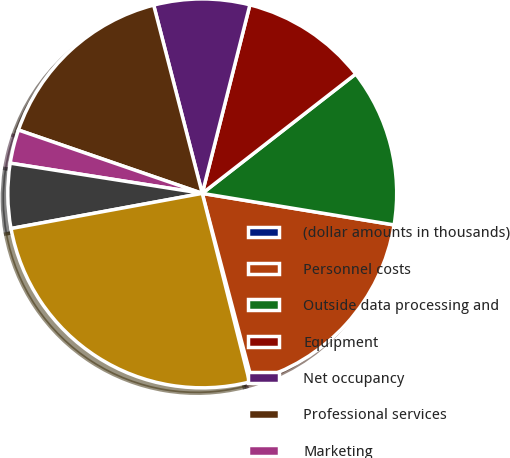Convert chart. <chart><loc_0><loc_0><loc_500><loc_500><pie_chart><fcel>(dollar amounts in thousands)<fcel>Personnel costs<fcel>Outside data processing and<fcel>Equipment<fcel>Net occupancy<fcel>Professional services<fcel>Marketing<fcel>Other expense<fcel>Total impact of significant<nl><fcel>0.22%<fcel>18.28%<fcel>13.12%<fcel>10.54%<fcel>7.96%<fcel>15.7%<fcel>2.8%<fcel>5.38%<fcel>26.02%<nl></chart> 